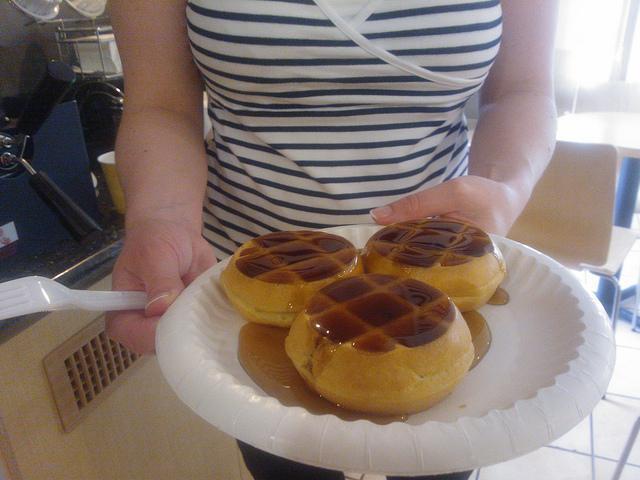How many elephants can be seen in the photo?
Give a very brief answer. 0. 